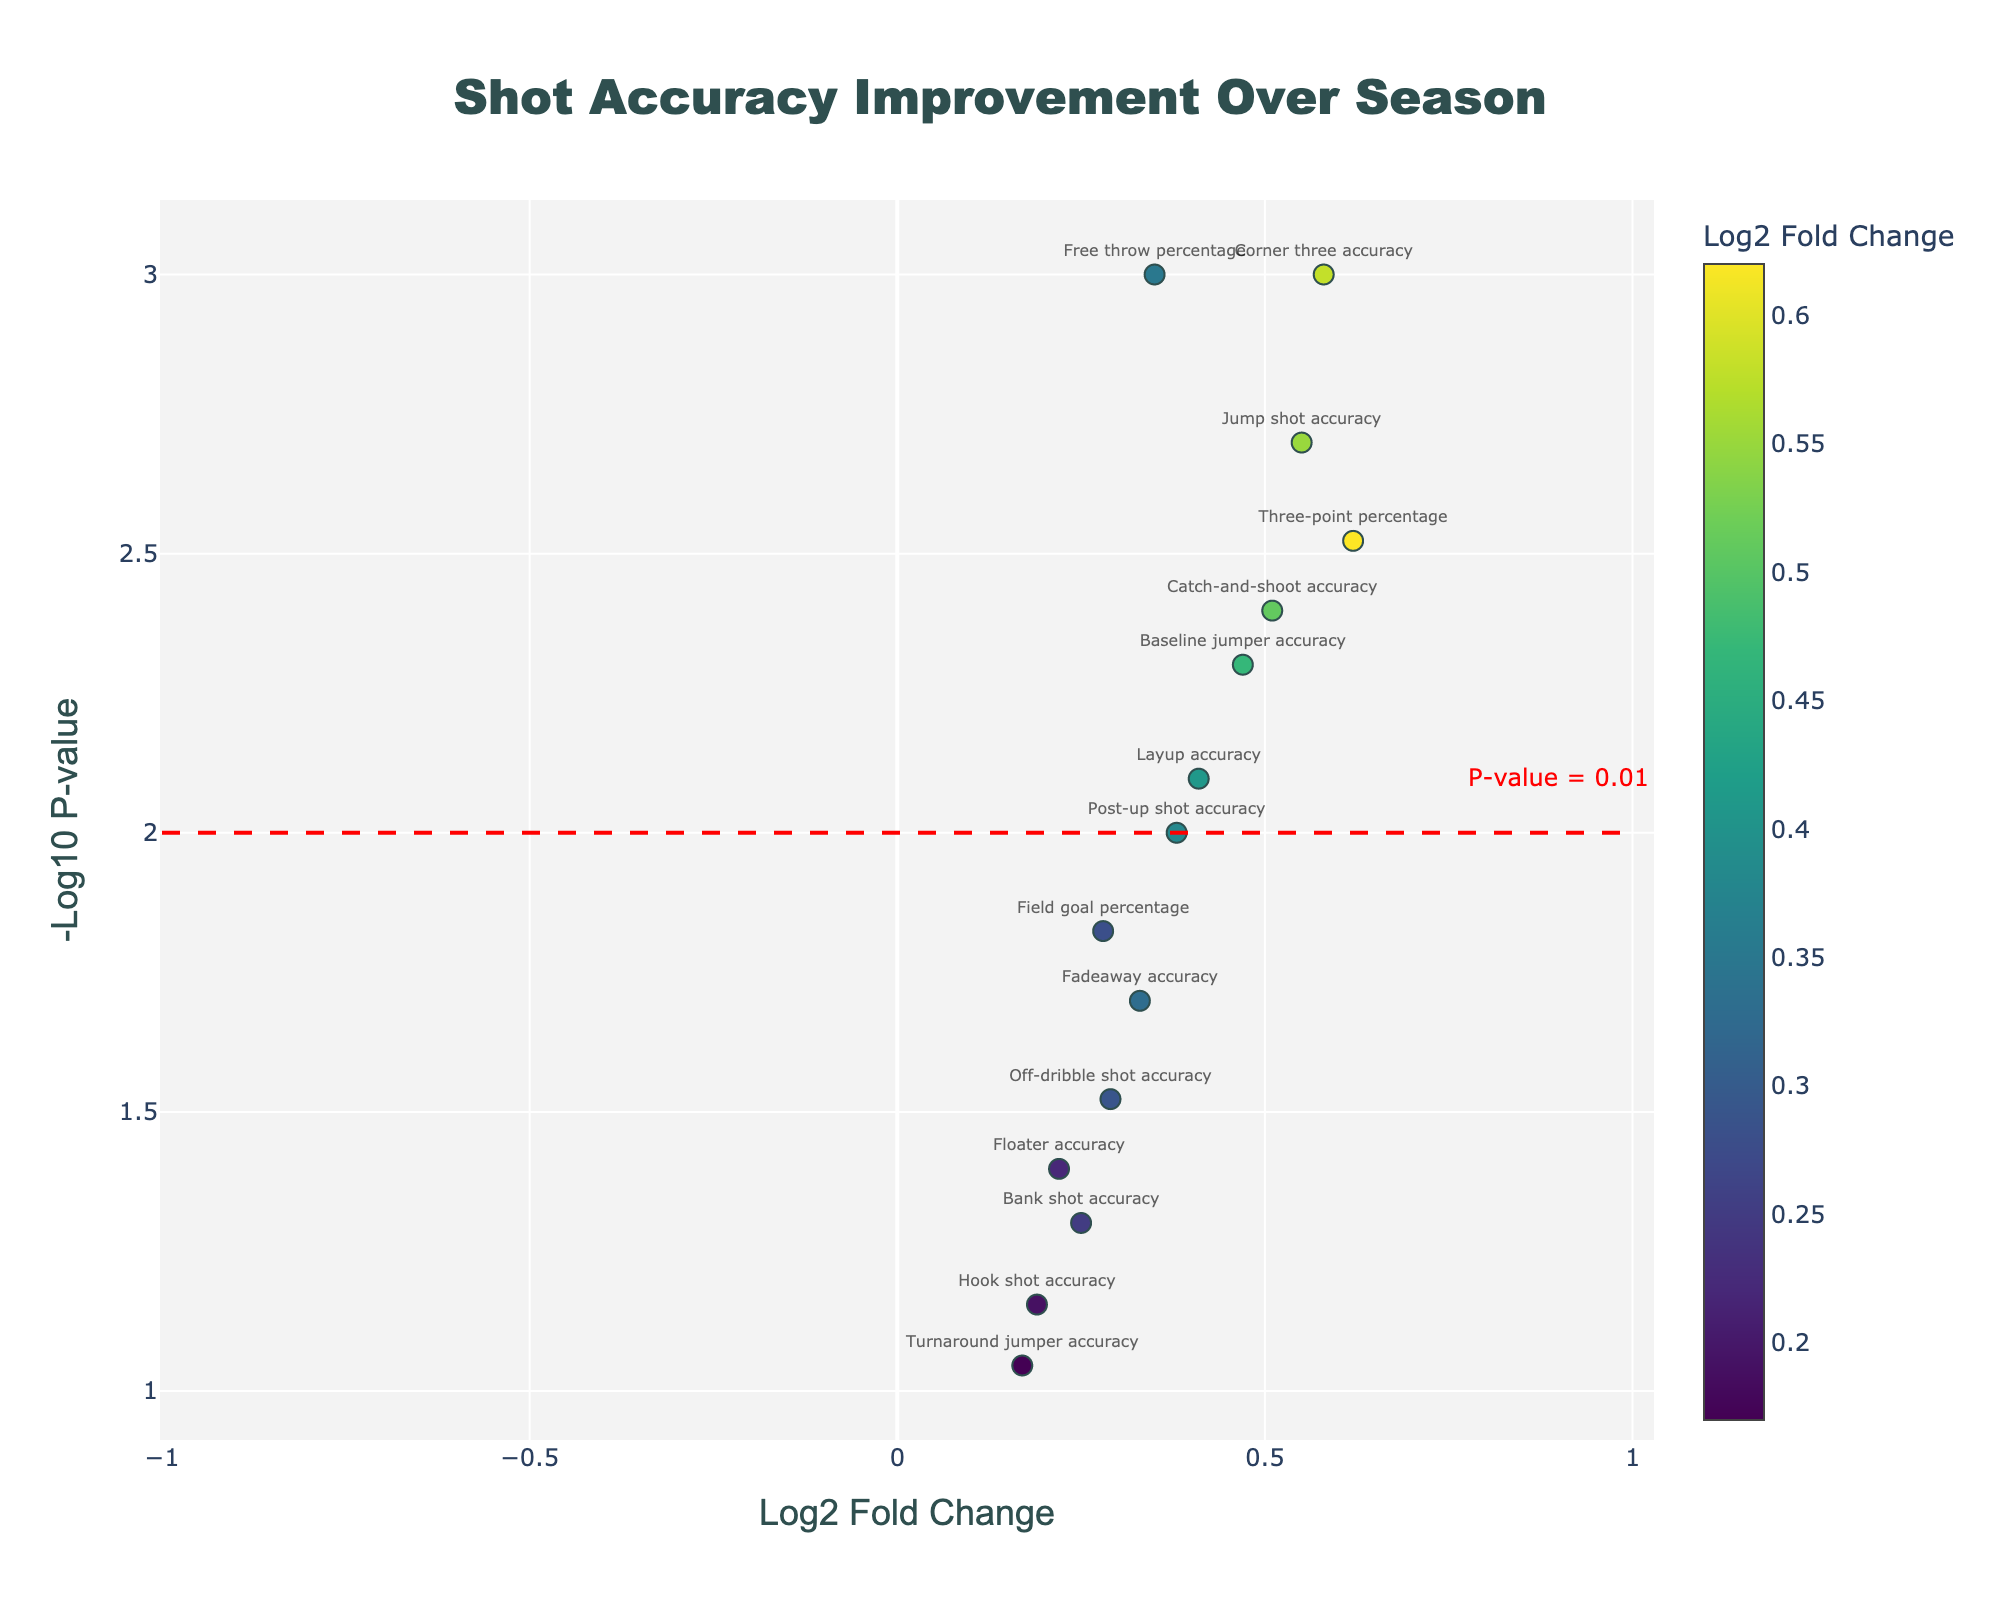What's the title of the figure? The title of the figure is found at the top center of the plot. It's labeled as "Shot Accuracy Improvement Over Season," indicating that the figure shows changes in shot accuracy for a basketball player.
Answer: Shot Accuracy Improvement Over Season What does the x-axis in the plot represent? The x-axis title is "Log2 Fold Change," which indicates the log2 scale of the fold change in shot accuracy improvement. This shows how much each shot type's accuracy has improved over the season.
Answer: Log2 Fold Change What does the y-axis in the plot represent? The y-axis title is "-Log10 P-value," which signifies the negative logarithm (base 10) of the p-value. A higher value indicates greater significance of improvement in shot accuracy.
Answer: -Log10 P-value Which shot type has the highest log2 fold change? The shot type with the highest log2 fold change is identified by looking at the point farthest to the right on the x-axis. In this case, it's the "Three-point percentage" with a log2 fold change of 0.62.
Answer: Three-point percentage Which shot type has the most significant improvement? The shot type with the most significant improvement can be found by looking at the highest point on the y-axis (-Log10 P-value). The "Free throw percentage" has the highest -Log10 P-value at approximately 3.
Answer: Free throw percentage How many shot types have a p-value less than 0.01? The dashed red line represents a p-value of 0.01, and shot types above this line have p-values less than 0.01. The shot types above the line are "Free throw percentage," "Three-point percentage," "Jump shot accuracy," "Baseline jumper accuracy," "Catch-and-shoot accuracy," and "Corner three accuracy," totaling to 6.
Answer: 6 Which shot types have a -Log10 P-value close to 2? Shot types with a -Log10 P-value around 2 are close to the red dashed line indicating a p-value of 0.01. The shot types near this line are "Field goal percentage" and "Post-up shot accuracy."
Answer: Field goal percentage, Post-up shot accuracy How many shot types show a negative log2 fold change? By looking at the points on the left side of the x-axis (negative log2 fold change), none of the shot types have a negative log2 fold change; all points are on the right side.
Answer: 0 Which shot type has the lowest -Log10 P-value, and what is its approximate value? The shot type with the lowest -Log10 P-value is "Turnaround jumper accuracy," as seen at the lowest point on the y-axis, with an approximate value close to 1.
Answer: Turnaround jumper accuracy, 1 